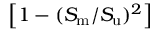<formula> <loc_0><loc_0><loc_500><loc_500>\left [ 1 - ( S _ { m } / S _ { u } ) ^ { 2 } \right ]</formula> 